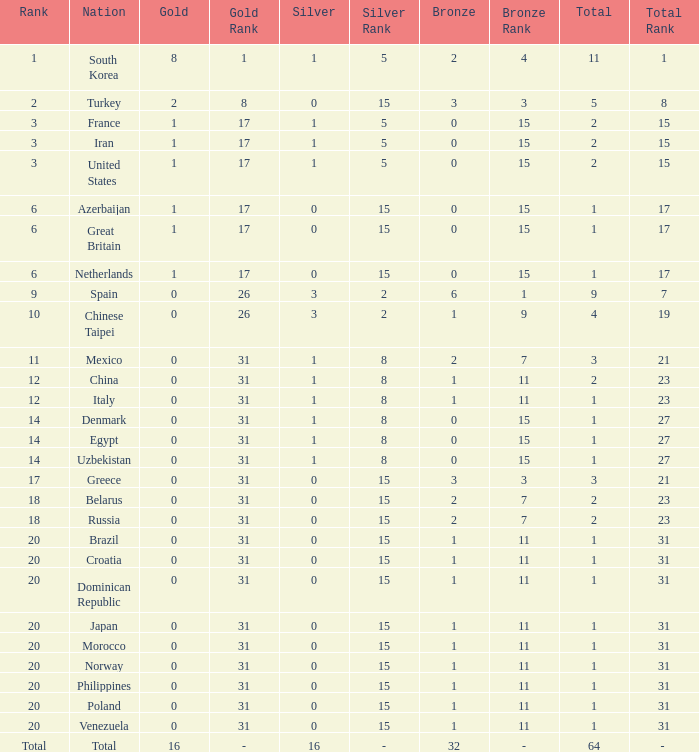What is the average total medals of the nation ranked 1 with less than 1 silver? None. 